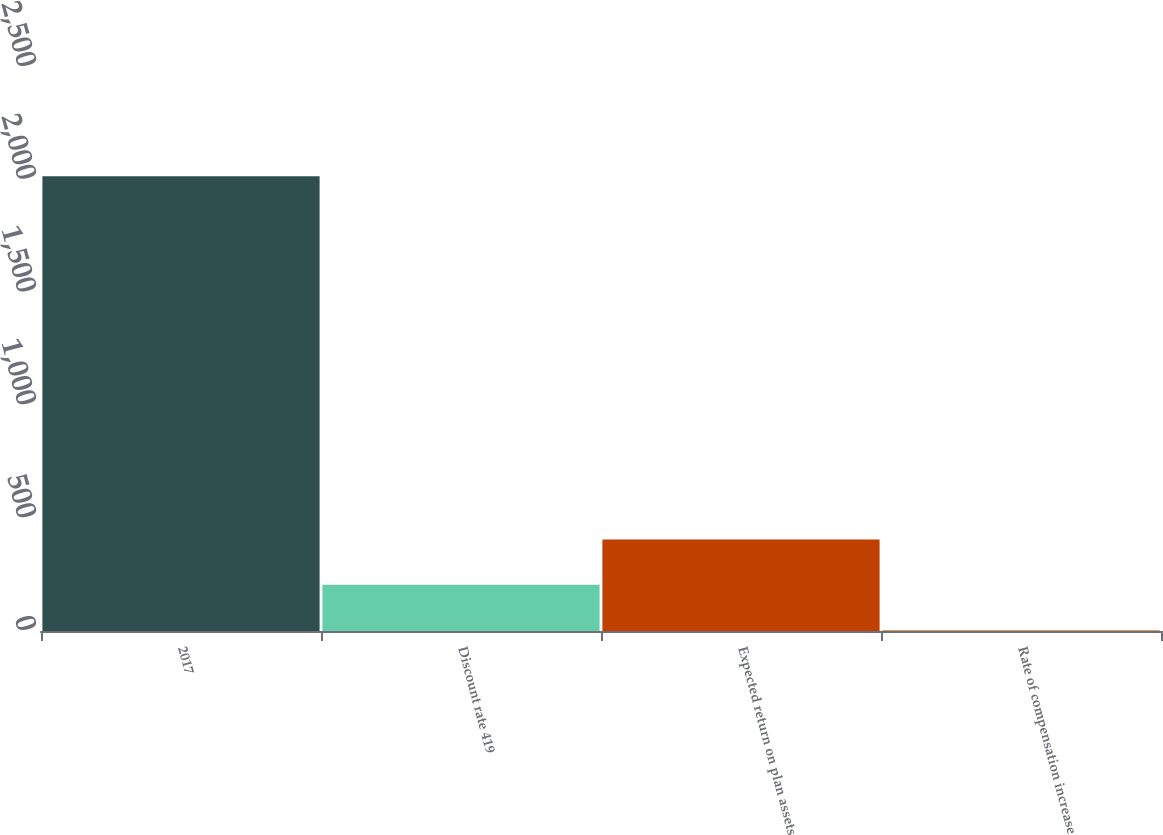Convert chart to OTSL. <chart><loc_0><loc_0><loc_500><loc_500><bar_chart><fcel>2017<fcel>Discount rate 419<fcel>Expected return on plan assets<fcel>Rate of compensation increase<nl><fcel>2016<fcel>204.53<fcel>405.81<fcel>3.25<nl></chart> 